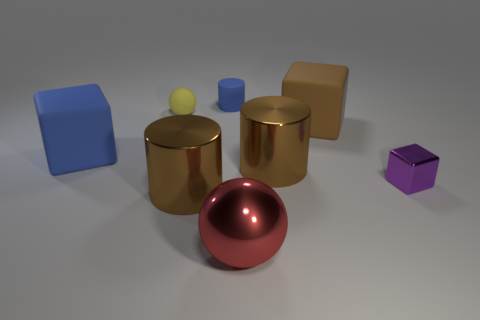Add 1 big metallic things. How many objects exist? 9 Subtract all large blocks. How many blocks are left? 1 Subtract all cyan spheres. How many brown cylinders are left? 2 Subtract all purple blocks. How many blocks are left? 2 Subtract all blocks. How many objects are left? 5 Add 6 rubber cubes. How many rubber cubes are left? 8 Add 8 big gray balls. How many big gray balls exist? 8 Subtract 1 brown cylinders. How many objects are left? 7 Subtract all red cylinders. Subtract all gray balls. How many cylinders are left? 3 Subtract all cyan cylinders. Subtract all shiny things. How many objects are left? 4 